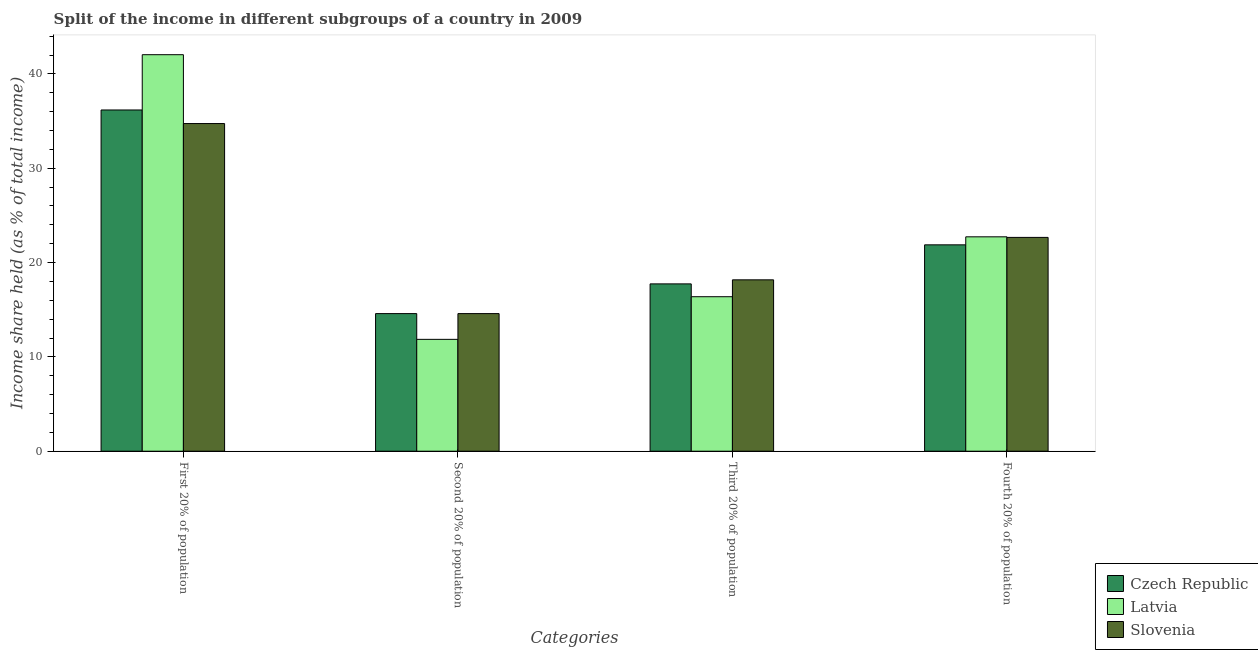Are the number of bars per tick equal to the number of legend labels?
Provide a short and direct response. Yes. How many bars are there on the 3rd tick from the right?
Keep it short and to the point. 3. What is the label of the 3rd group of bars from the left?
Offer a terse response. Third 20% of population. What is the share of the income held by third 20% of the population in Slovenia?
Your response must be concise. 18.17. Across all countries, what is the maximum share of the income held by second 20% of the population?
Offer a very short reply. 14.59. Across all countries, what is the minimum share of the income held by third 20% of the population?
Keep it short and to the point. 16.38. In which country was the share of the income held by third 20% of the population maximum?
Ensure brevity in your answer.  Slovenia. In which country was the share of the income held by first 20% of the population minimum?
Provide a succinct answer. Slovenia. What is the total share of the income held by first 20% of the population in the graph?
Provide a succinct answer. 112.96. What is the difference between the share of the income held by fourth 20% of the population in Czech Republic and that in Slovenia?
Provide a succinct answer. -0.79. What is the difference between the share of the income held by first 20% of the population in Latvia and the share of the income held by third 20% of the population in Czech Republic?
Your answer should be compact. 24.3. What is the average share of the income held by second 20% of the population per country?
Provide a short and direct response. 13.68. What is the difference between the share of the income held by second 20% of the population and share of the income held by fourth 20% of the population in Latvia?
Provide a succinct answer. -10.87. In how many countries, is the share of the income held by second 20% of the population greater than 42 %?
Give a very brief answer. 0. What is the ratio of the share of the income held by second 20% of the population in Czech Republic to that in Latvia?
Keep it short and to the point. 1.23. Is the share of the income held by fourth 20% of the population in Slovenia less than that in Latvia?
Make the answer very short. Yes. Is the difference between the share of the income held by first 20% of the population in Latvia and Czech Republic greater than the difference between the share of the income held by fourth 20% of the population in Latvia and Czech Republic?
Give a very brief answer. Yes. What is the difference between the highest and the second highest share of the income held by second 20% of the population?
Give a very brief answer. 0. What is the difference between the highest and the lowest share of the income held by second 20% of the population?
Ensure brevity in your answer.  2.73. In how many countries, is the share of the income held by second 20% of the population greater than the average share of the income held by second 20% of the population taken over all countries?
Your answer should be compact. 2. Is it the case that in every country, the sum of the share of the income held by fourth 20% of the population and share of the income held by third 20% of the population is greater than the sum of share of the income held by first 20% of the population and share of the income held by second 20% of the population?
Make the answer very short. No. What does the 1st bar from the left in Fourth 20% of population represents?
Ensure brevity in your answer.  Czech Republic. What does the 1st bar from the right in First 20% of population represents?
Your answer should be compact. Slovenia. What is the difference between two consecutive major ticks on the Y-axis?
Your response must be concise. 10. Are the values on the major ticks of Y-axis written in scientific E-notation?
Your answer should be compact. No. Does the graph contain any zero values?
Ensure brevity in your answer.  No. Does the graph contain grids?
Your answer should be compact. No. How many legend labels are there?
Offer a terse response. 3. What is the title of the graph?
Offer a very short reply. Split of the income in different subgroups of a country in 2009. What is the label or title of the X-axis?
Keep it short and to the point. Categories. What is the label or title of the Y-axis?
Your answer should be very brief. Income share held (as % of total income). What is the Income share held (as % of total income) in Czech Republic in First 20% of population?
Provide a succinct answer. 36.18. What is the Income share held (as % of total income) in Latvia in First 20% of population?
Offer a terse response. 42.04. What is the Income share held (as % of total income) of Slovenia in First 20% of population?
Your answer should be compact. 34.74. What is the Income share held (as % of total income) of Czech Republic in Second 20% of population?
Keep it short and to the point. 14.59. What is the Income share held (as % of total income) in Latvia in Second 20% of population?
Your answer should be very brief. 11.86. What is the Income share held (as % of total income) of Slovenia in Second 20% of population?
Your response must be concise. 14.59. What is the Income share held (as % of total income) in Czech Republic in Third 20% of population?
Give a very brief answer. 17.74. What is the Income share held (as % of total income) of Latvia in Third 20% of population?
Give a very brief answer. 16.38. What is the Income share held (as % of total income) of Slovenia in Third 20% of population?
Your answer should be very brief. 18.17. What is the Income share held (as % of total income) in Czech Republic in Fourth 20% of population?
Your response must be concise. 21.88. What is the Income share held (as % of total income) of Latvia in Fourth 20% of population?
Provide a succinct answer. 22.73. What is the Income share held (as % of total income) of Slovenia in Fourth 20% of population?
Your response must be concise. 22.67. Across all Categories, what is the maximum Income share held (as % of total income) in Czech Republic?
Your response must be concise. 36.18. Across all Categories, what is the maximum Income share held (as % of total income) in Latvia?
Provide a succinct answer. 42.04. Across all Categories, what is the maximum Income share held (as % of total income) in Slovenia?
Your answer should be very brief. 34.74. Across all Categories, what is the minimum Income share held (as % of total income) of Czech Republic?
Provide a succinct answer. 14.59. Across all Categories, what is the minimum Income share held (as % of total income) of Latvia?
Offer a terse response. 11.86. Across all Categories, what is the minimum Income share held (as % of total income) of Slovenia?
Give a very brief answer. 14.59. What is the total Income share held (as % of total income) of Czech Republic in the graph?
Give a very brief answer. 90.39. What is the total Income share held (as % of total income) in Latvia in the graph?
Your answer should be compact. 93.01. What is the total Income share held (as % of total income) of Slovenia in the graph?
Your answer should be very brief. 90.17. What is the difference between the Income share held (as % of total income) of Czech Republic in First 20% of population and that in Second 20% of population?
Keep it short and to the point. 21.59. What is the difference between the Income share held (as % of total income) of Latvia in First 20% of population and that in Second 20% of population?
Offer a terse response. 30.18. What is the difference between the Income share held (as % of total income) of Slovenia in First 20% of population and that in Second 20% of population?
Your answer should be compact. 20.15. What is the difference between the Income share held (as % of total income) in Czech Republic in First 20% of population and that in Third 20% of population?
Your answer should be very brief. 18.44. What is the difference between the Income share held (as % of total income) of Latvia in First 20% of population and that in Third 20% of population?
Your answer should be compact. 25.66. What is the difference between the Income share held (as % of total income) of Slovenia in First 20% of population and that in Third 20% of population?
Keep it short and to the point. 16.57. What is the difference between the Income share held (as % of total income) in Czech Republic in First 20% of population and that in Fourth 20% of population?
Give a very brief answer. 14.3. What is the difference between the Income share held (as % of total income) of Latvia in First 20% of population and that in Fourth 20% of population?
Your response must be concise. 19.31. What is the difference between the Income share held (as % of total income) in Slovenia in First 20% of population and that in Fourth 20% of population?
Your answer should be compact. 12.07. What is the difference between the Income share held (as % of total income) of Czech Republic in Second 20% of population and that in Third 20% of population?
Your answer should be very brief. -3.15. What is the difference between the Income share held (as % of total income) of Latvia in Second 20% of population and that in Third 20% of population?
Your answer should be compact. -4.52. What is the difference between the Income share held (as % of total income) in Slovenia in Second 20% of population and that in Third 20% of population?
Offer a very short reply. -3.58. What is the difference between the Income share held (as % of total income) of Czech Republic in Second 20% of population and that in Fourth 20% of population?
Offer a very short reply. -7.29. What is the difference between the Income share held (as % of total income) in Latvia in Second 20% of population and that in Fourth 20% of population?
Your response must be concise. -10.87. What is the difference between the Income share held (as % of total income) of Slovenia in Second 20% of population and that in Fourth 20% of population?
Your answer should be compact. -8.08. What is the difference between the Income share held (as % of total income) of Czech Republic in Third 20% of population and that in Fourth 20% of population?
Offer a terse response. -4.14. What is the difference between the Income share held (as % of total income) of Latvia in Third 20% of population and that in Fourth 20% of population?
Make the answer very short. -6.35. What is the difference between the Income share held (as % of total income) in Slovenia in Third 20% of population and that in Fourth 20% of population?
Provide a succinct answer. -4.5. What is the difference between the Income share held (as % of total income) of Czech Republic in First 20% of population and the Income share held (as % of total income) of Latvia in Second 20% of population?
Your response must be concise. 24.32. What is the difference between the Income share held (as % of total income) of Czech Republic in First 20% of population and the Income share held (as % of total income) of Slovenia in Second 20% of population?
Ensure brevity in your answer.  21.59. What is the difference between the Income share held (as % of total income) in Latvia in First 20% of population and the Income share held (as % of total income) in Slovenia in Second 20% of population?
Your answer should be compact. 27.45. What is the difference between the Income share held (as % of total income) in Czech Republic in First 20% of population and the Income share held (as % of total income) in Latvia in Third 20% of population?
Your answer should be very brief. 19.8. What is the difference between the Income share held (as % of total income) in Czech Republic in First 20% of population and the Income share held (as % of total income) in Slovenia in Third 20% of population?
Keep it short and to the point. 18.01. What is the difference between the Income share held (as % of total income) of Latvia in First 20% of population and the Income share held (as % of total income) of Slovenia in Third 20% of population?
Your response must be concise. 23.87. What is the difference between the Income share held (as % of total income) in Czech Republic in First 20% of population and the Income share held (as % of total income) in Latvia in Fourth 20% of population?
Make the answer very short. 13.45. What is the difference between the Income share held (as % of total income) in Czech Republic in First 20% of population and the Income share held (as % of total income) in Slovenia in Fourth 20% of population?
Provide a succinct answer. 13.51. What is the difference between the Income share held (as % of total income) in Latvia in First 20% of population and the Income share held (as % of total income) in Slovenia in Fourth 20% of population?
Offer a very short reply. 19.37. What is the difference between the Income share held (as % of total income) of Czech Republic in Second 20% of population and the Income share held (as % of total income) of Latvia in Third 20% of population?
Your response must be concise. -1.79. What is the difference between the Income share held (as % of total income) of Czech Republic in Second 20% of population and the Income share held (as % of total income) of Slovenia in Third 20% of population?
Give a very brief answer. -3.58. What is the difference between the Income share held (as % of total income) in Latvia in Second 20% of population and the Income share held (as % of total income) in Slovenia in Third 20% of population?
Offer a very short reply. -6.31. What is the difference between the Income share held (as % of total income) in Czech Republic in Second 20% of population and the Income share held (as % of total income) in Latvia in Fourth 20% of population?
Your answer should be compact. -8.14. What is the difference between the Income share held (as % of total income) in Czech Republic in Second 20% of population and the Income share held (as % of total income) in Slovenia in Fourth 20% of population?
Give a very brief answer. -8.08. What is the difference between the Income share held (as % of total income) of Latvia in Second 20% of population and the Income share held (as % of total income) of Slovenia in Fourth 20% of population?
Offer a very short reply. -10.81. What is the difference between the Income share held (as % of total income) of Czech Republic in Third 20% of population and the Income share held (as % of total income) of Latvia in Fourth 20% of population?
Your answer should be very brief. -4.99. What is the difference between the Income share held (as % of total income) of Czech Republic in Third 20% of population and the Income share held (as % of total income) of Slovenia in Fourth 20% of population?
Make the answer very short. -4.93. What is the difference between the Income share held (as % of total income) of Latvia in Third 20% of population and the Income share held (as % of total income) of Slovenia in Fourth 20% of population?
Ensure brevity in your answer.  -6.29. What is the average Income share held (as % of total income) in Czech Republic per Categories?
Make the answer very short. 22.6. What is the average Income share held (as % of total income) of Latvia per Categories?
Provide a short and direct response. 23.25. What is the average Income share held (as % of total income) in Slovenia per Categories?
Your response must be concise. 22.54. What is the difference between the Income share held (as % of total income) in Czech Republic and Income share held (as % of total income) in Latvia in First 20% of population?
Your answer should be very brief. -5.86. What is the difference between the Income share held (as % of total income) in Czech Republic and Income share held (as % of total income) in Slovenia in First 20% of population?
Provide a succinct answer. 1.44. What is the difference between the Income share held (as % of total income) of Latvia and Income share held (as % of total income) of Slovenia in First 20% of population?
Your response must be concise. 7.3. What is the difference between the Income share held (as % of total income) of Czech Republic and Income share held (as % of total income) of Latvia in Second 20% of population?
Provide a short and direct response. 2.73. What is the difference between the Income share held (as % of total income) of Latvia and Income share held (as % of total income) of Slovenia in Second 20% of population?
Give a very brief answer. -2.73. What is the difference between the Income share held (as % of total income) of Czech Republic and Income share held (as % of total income) of Latvia in Third 20% of population?
Give a very brief answer. 1.36. What is the difference between the Income share held (as % of total income) of Czech Republic and Income share held (as % of total income) of Slovenia in Third 20% of population?
Provide a succinct answer. -0.43. What is the difference between the Income share held (as % of total income) in Latvia and Income share held (as % of total income) in Slovenia in Third 20% of population?
Your answer should be very brief. -1.79. What is the difference between the Income share held (as % of total income) of Czech Republic and Income share held (as % of total income) of Latvia in Fourth 20% of population?
Make the answer very short. -0.85. What is the difference between the Income share held (as % of total income) of Czech Republic and Income share held (as % of total income) of Slovenia in Fourth 20% of population?
Offer a terse response. -0.79. What is the difference between the Income share held (as % of total income) in Latvia and Income share held (as % of total income) in Slovenia in Fourth 20% of population?
Ensure brevity in your answer.  0.06. What is the ratio of the Income share held (as % of total income) of Czech Republic in First 20% of population to that in Second 20% of population?
Give a very brief answer. 2.48. What is the ratio of the Income share held (as % of total income) of Latvia in First 20% of population to that in Second 20% of population?
Provide a short and direct response. 3.54. What is the ratio of the Income share held (as % of total income) in Slovenia in First 20% of population to that in Second 20% of population?
Ensure brevity in your answer.  2.38. What is the ratio of the Income share held (as % of total income) in Czech Republic in First 20% of population to that in Third 20% of population?
Your answer should be compact. 2.04. What is the ratio of the Income share held (as % of total income) in Latvia in First 20% of population to that in Third 20% of population?
Your answer should be compact. 2.57. What is the ratio of the Income share held (as % of total income) of Slovenia in First 20% of population to that in Third 20% of population?
Your response must be concise. 1.91. What is the ratio of the Income share held (as % of total income) of Czech Republic in First 20% of population to that in Fourth 20% of population?
Your answer should be very brief. 1.65. What is the ratio of the Income share held (as % of total income) in Latvia in First 20% of population to that in Fourth 20% of population?
Your answer should be very brief. 1.85. What is the ratio of the Income share held (as % of total income) of Slovenia in First 20% of population to that in Fourth 20% of population?
Give a very brief answer. 1.53. What is the ratio of the Income share held (as % of total income) in Czech Republic in Second 20% of population to that in Third 20% of population?
Give a very brief answer. 0.82. What is the ratio of the Income share held (as % of total income) in Latvia in Second 20% of population to that in Third 20% of population?
Give a very brief answer. 0.72. What is the ratio of the Income share held (as % of total income) in Slovenia in Second 20% of population to that in Third 20% of population?
Make the answer very short. 0.8. What is the ratio of the Income share held (as % of total income) in Czech Republic in Second 20% of population to that in Fourth 20% of population?
Keep it short and to the point. 0.67. What is the ratio of the Income share held (as % of total income) of Latvia in Second 20% of population to that in Fourth 20% of population?
Your answer should be compact. 0.52. What is the ratio of the Income share held (as % of total income) of Slovenia in Second 20% of population to that in Fourth 20% of population?
Offer a terse response. 0.64. What is the ratio of the Income share held (as % of total income) of Czech Republic in Third 20% of population to that in Fourth 20% of population?
Give a very brief answer. 0.81. What is the ratio of the Income share held (as % of total income) in Latvia in Third 20% of population to that in Fourth 20% of population?
Provide a short and direct response. 0.72. What is the ratio of the Income share held (as % of total income) of Slovenia in Third 20% of population to that in Fourth 20% of population?
Your answer should be very brief. 0.8. What is the difference between the highest and the second highest Income share held (as % of total income) of Latvia?
Your answer should be very brief. 19.31. What is the difference between the highest and the second highest Income share held (as % of total income) of Slovenia?
Provide a succinct answer. 12.07. What is the difference between the highest and the lowest Income share held (as % of total income) of Czech Republic?
Give a very brief answer. 21.59. What is the difference between the highest and the lowest Income share held (as % of total income) of Latvia?
Provide a succinct answer. 30.18. What is the difference between the highest and the lowest Income share held (as % of total income) of Slovenia?
Ensure brevity in your answer.  20.15. 